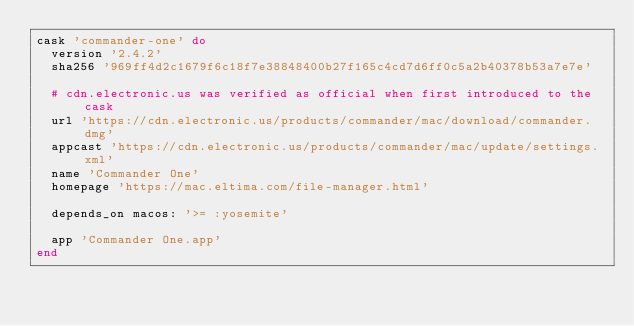<code> <loc_0><loc_0><loc_500><loc_500><_Ruby_>cask 'commander-one' do
  version '2.4.2'
  sha256 '969ff4d2c1679f6c18f7e38848400b27f165c4cd7d6ff0c5a2b40378b53a7e7e'

  # cdn.electronic.us was verified as official when first introduced to the cask
  url 'https://cdn.electronic.us/products/commander/mac/download/commander.dmg'
  appcast 'https://cdn.electronic.us/products/commander/mac/update/settings.xml'
  name 'Commander One'
  homepage 'https://mac.eltima.com/file-manager.html'

  depends_on macos: '>= :yosemite'

  app 'Commander One.app'
end
</code> 